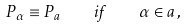<formula> <loc_0><loc_0><loc_500><loc_500>P _ { \alpha } \equiv P _ { a } \quad i f \quad \alpha \in a \, ,</formula> 